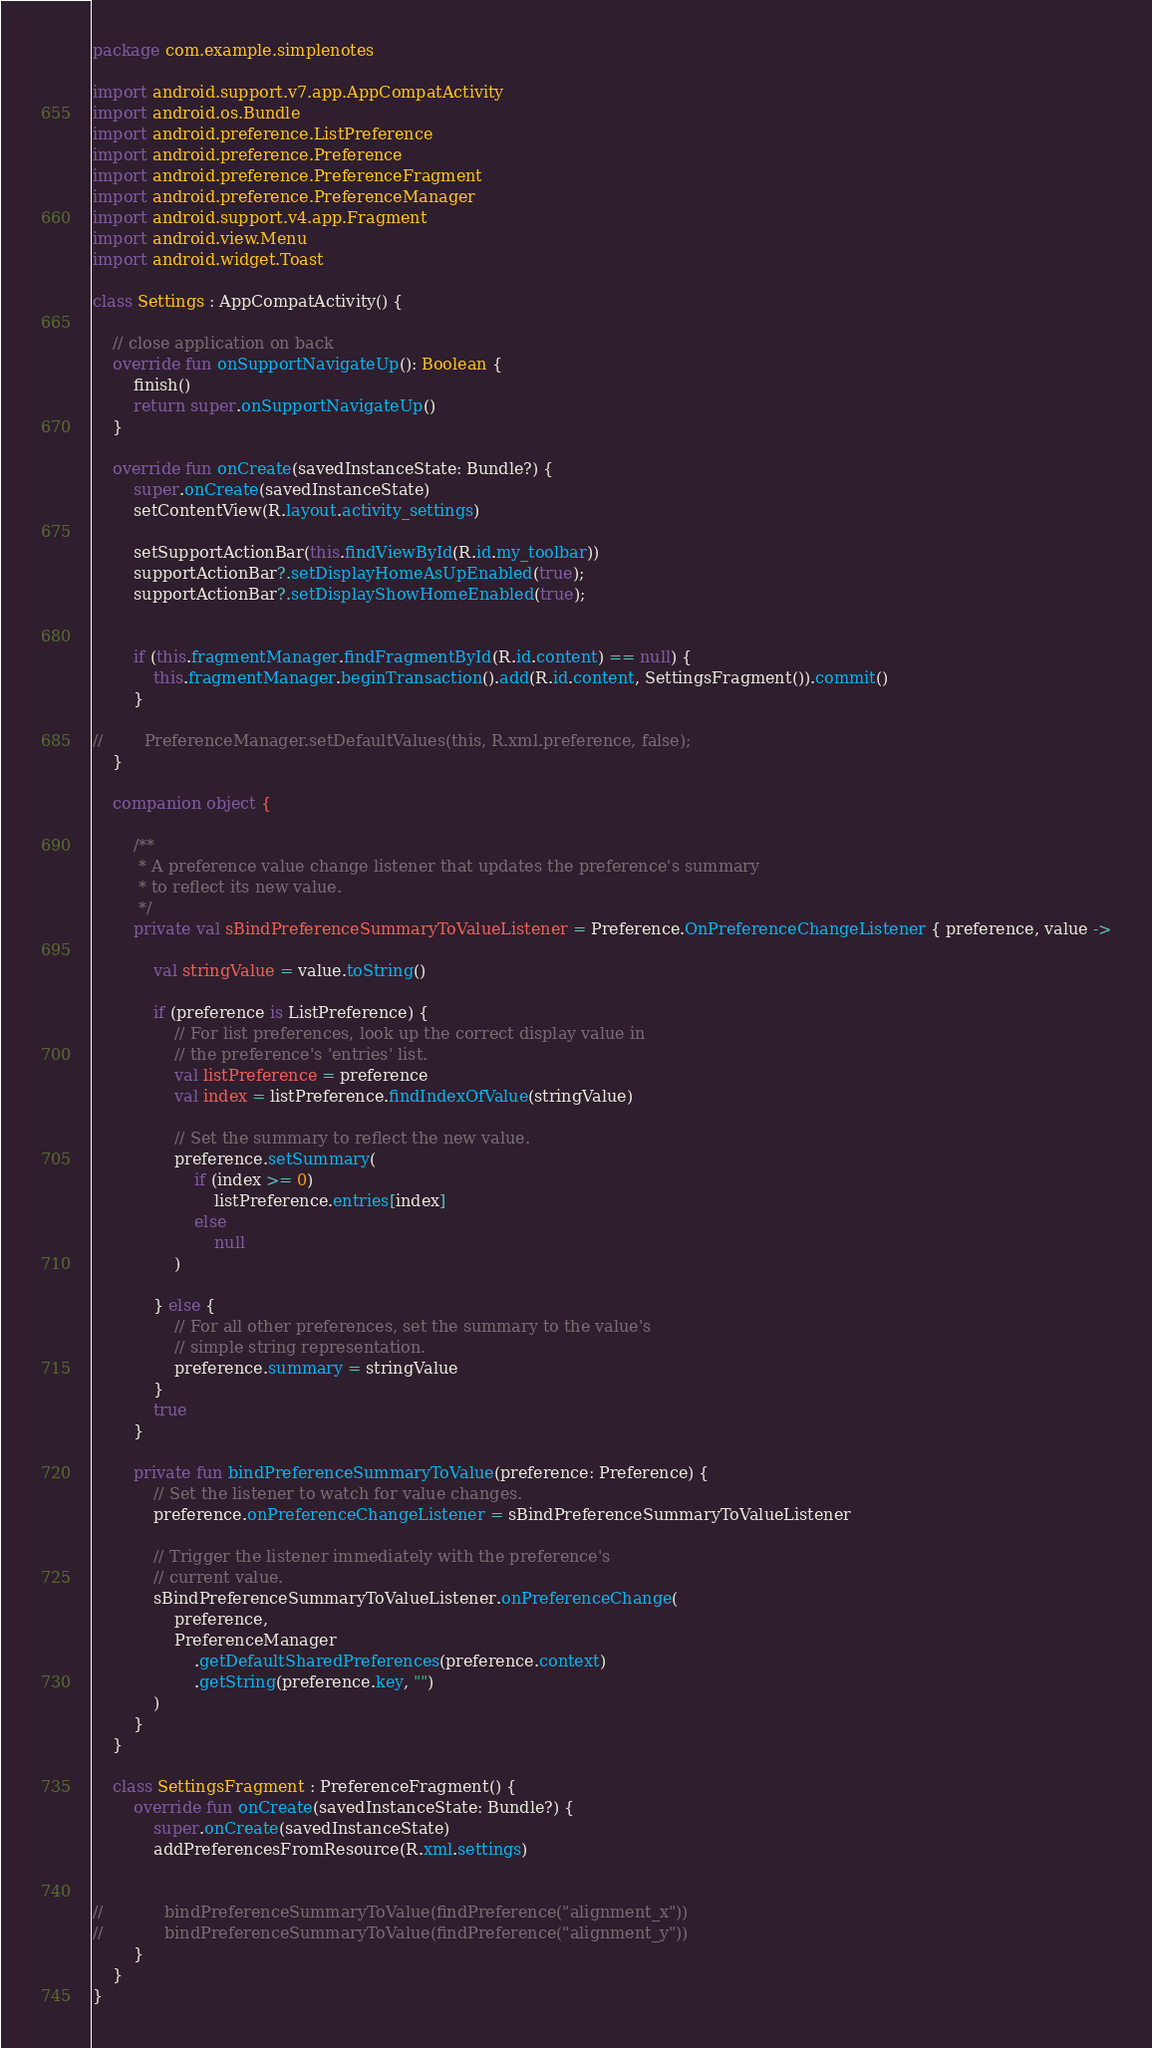Convert code to text. <code><loc_0><loc_0><loc_500><loc_500><_Kotlin_>package com.example.simplenotes

import android.support.v7.app.AppCompatActivity
import android.os.Bundle
import android.preference.ListPreference
import android.preference.Preference
import android.preference.PreferenceFragment
import android.preference.PreferenceManager
import android.support.v4.app.Fragment
import android.view.Menu
import android.widget.Toast

class Settings : AppCompatActivity() {

    // close application on back
    override fun onSupportNavigateUp(): Boolean {
        finish()
        return super.onSupportNavigateUp()
    }

    override fun onCreate(savedInstanceState: Bundle?) {
        super.onCreate(savedInstanceState)
        setContentView(R.layout.activity_settings)

        setSupportActionBar(this.findViewById(R.id.my_toolbar))
        supportActionBar?.setDisplayHomeAsUpEnabled(true);
        supportActionBar?.setDisplayShowHomeEnabled(true);


        if (this.fragmentManager.findFragmentById(R.id.content) == null) {
            this.fragmentManager.beginTransaction().add(R.id.content, SettingsFragment()).commit()
        }

//        PreferenceManager.setDefaultValues(this, R.xml.preference, false);
    }

    companion object {

        /**
         * A preference value change listener that updates the preference's summary
         * to reflect its new value.
         */
        private val sBindPreferenceSummaryToValueListener = Preference.OnPreferenceChangeListener { preference, value ->

            val stringValue = value.toString()

            if (preference is ListPreference) {
                // For list preferences, look up the correct display value in
                // the preference's 'entries' list.
                val listPreference = preference
                val index = listPreference.findIndexOfValue(stringValue)

                // Set the summary to reflect the new value.
                preference.setSummary(
                    if (index >= 0)
                        listPreference.entries[index]
                    else
                        null
                )

            } else {
                // For all other preferences, set the summary to the value's
                // simple string representation.
                preference.summary = stringValue
            }
            true
        }

        private fun bindPreferenceSummaryToValue(preference: Preference) {
            // Set the listener to watch for value changes.
            preference.onPreferenceChangeListener = sBindPreferenceSummaryToValueListener

            // Trigger the listener immediately with the preference's
            // current value.
            sBindPreferenceSummaryToValueListener.onPreferenceChange(
                preference,
                PreferenceManager
                    .getDefaultSharedPreferences(preference.context)
                    .getString(preference.key, "")
            )
        }
    }

    class SettingsFragment : PreferenceFragment() {
        override fun onCreate(savedInstanceState: Bundle?) {
            super.onCreate(savedInstanceState)
            addPreferencesFromResource(R.xml.settings)


//            bindPreferenceSummaryToValue(findPreference("alignment_x"))
//            bindPreferenceSummaryToValue(findPreference("alignment_y"))
        }
    }
}
</code> 